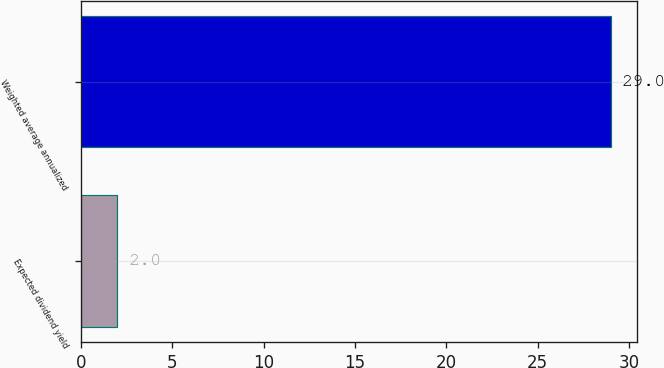Convert chart to OTSL. <chart><loc_0><loc_0><loc_500><loc_500><bar_chart><fcel>Expected dividend yield<fcel>Weighted average annualized<nl><fcel>2<fcel>29<nl></chart> 